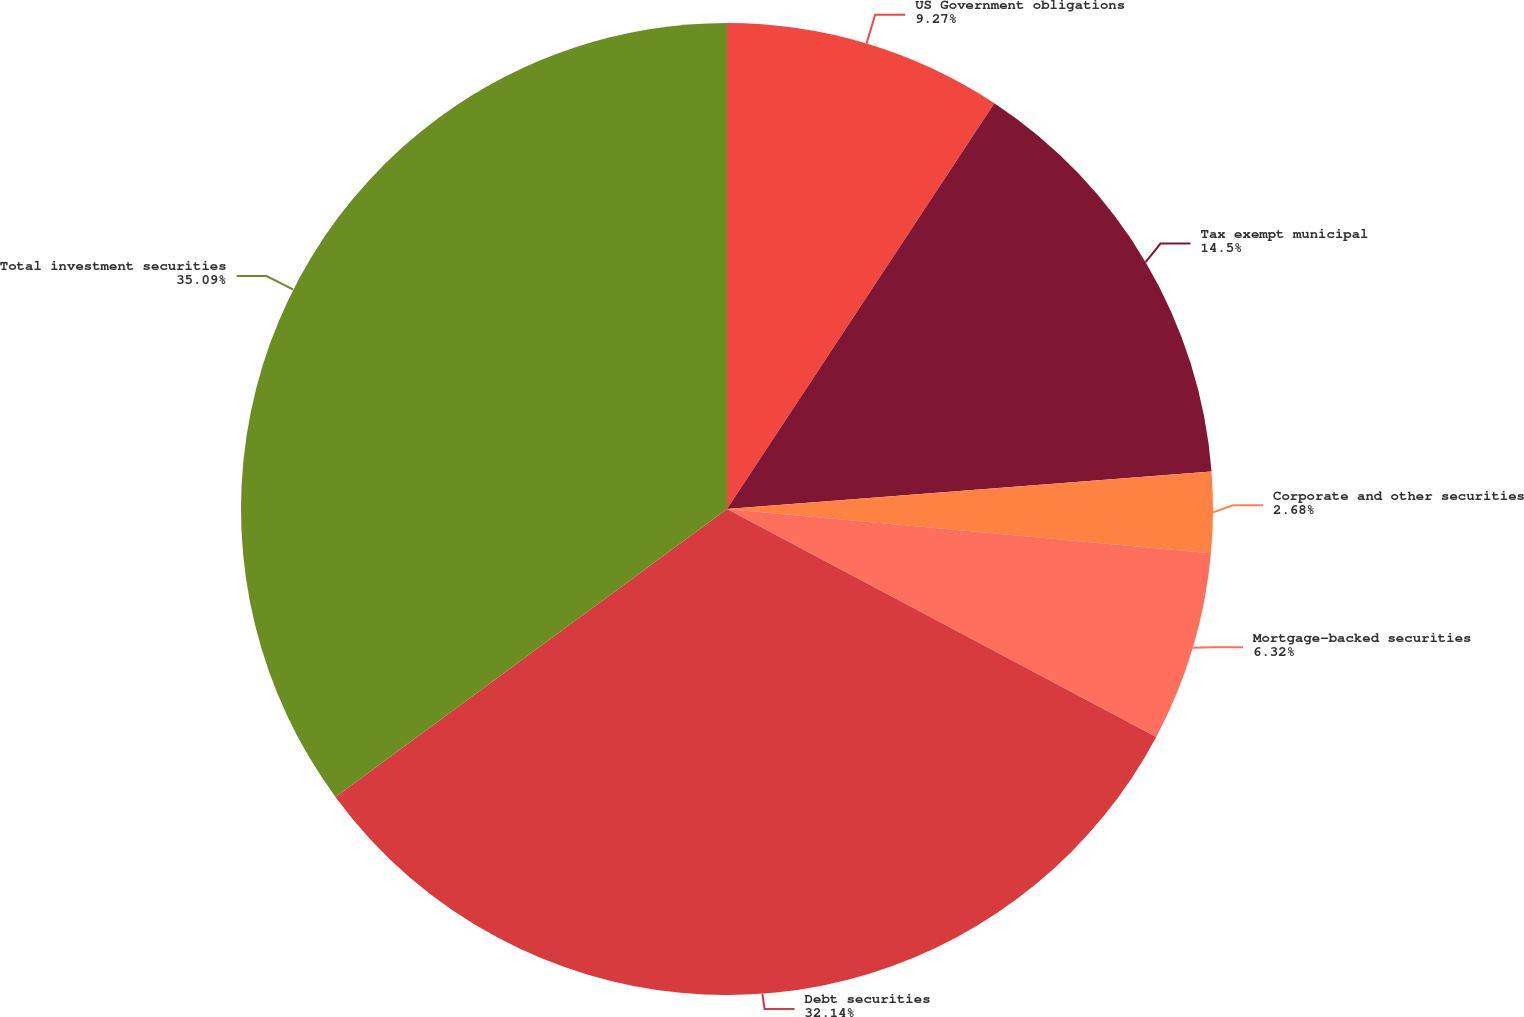Convert chart. <chart><loc_0><loc_0><loc_500><loc_500><pie_chart><fcel>US Government obligations<fcel>Tax exempt municipal<fcel>Corporate and other securities<fcel>Mortgage-backed securities<fcel>Debt securities<fcel>Total investment securities<nl><fcel>9.27%<fcel>14.5%<fcel>2.68%<fcel>6.32%<fcel>32.14%<fcel>35.09%<nl></chart> 